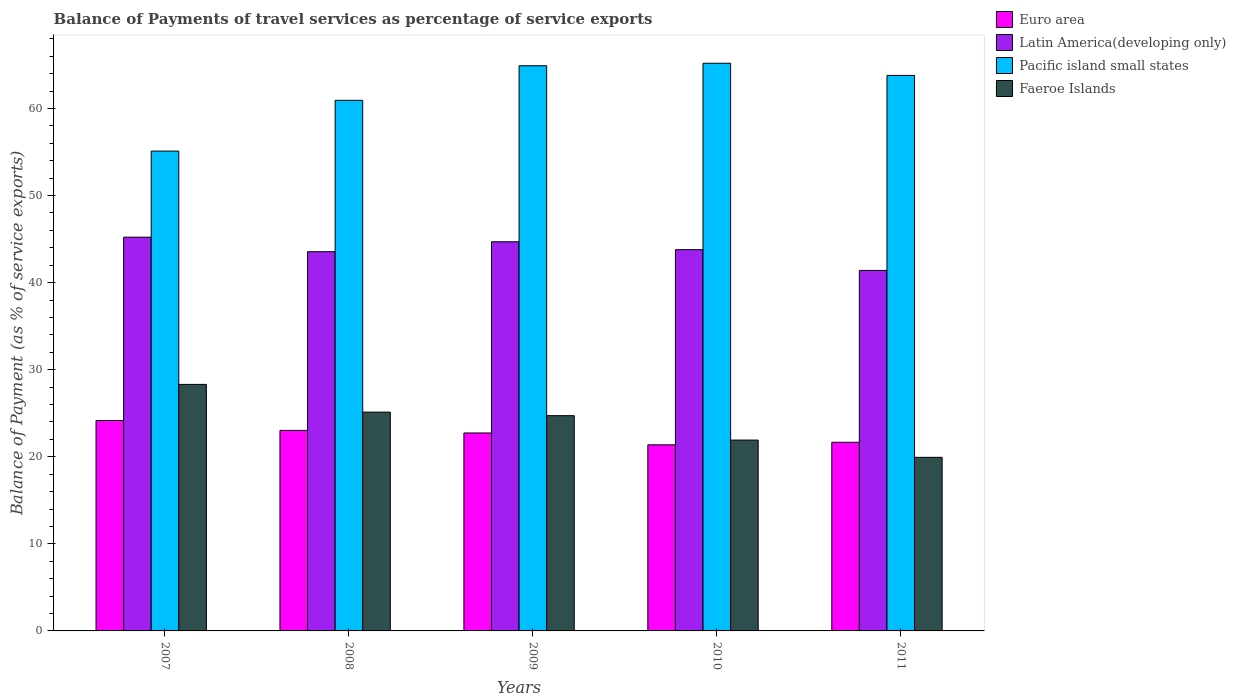How many groups of bars are there?
Keep it short and to the point. 5. Are the number of bars on each tick of the X-axis equal?
Offer a terse response. Yes. How many bars are there on the 3rd tick from the left?
Give a very brief answer. 4. How many bars are there on the 3rd tick from the right?
Give a very brief answer. 4. What is the label of the 2nd group of bars from the left?
Offer a very short reply. 2008. In how many cases, is the number of bars for a given year not equal to the number of legend labels?
Offer a very short reply. 0. What is the balance of payments of travel services in Pacific island small states in 2010?
Offer a terse response. 65.19. Across all years, what is the maximum balance of payments of travel services in Latin America(developing only)?
Keep it short and to the point. 45.22. Across all years, what is the minimum balance of payments of travel services in Faeroe Islands?
Give a very brief answer. 19.94. In which year was the balance of payments of travel services in Faeroe Islands maximum?
Keep it short and to the point. 2007. In which year was the balance of payments of travel services in Pacific island small states minimum?
Offer a very short reply. 2007. What is the total balance of payments of travel services in Faeroe Islands in the graph?
Make the answer very short. 120.01. What is the difference between the balance of payments of travel services in Euro area in 2009 and that in 2011?
Your answer should be compact. 1.07. What is the difference between the balance of payments of travel services in Euro area in 2008 and the balance of payments of travel services in Faeroe Islands in 2011?
Your answer should be very brief. 3.09. What is the average balance of payments of travel services in Latin America(developing only) per year?
Make the answer very short. 43.73. In the year 2009, what is the difference between the balance of payments of travel services in Pacific island small states and balance of payments of travel services in Euro area?
Offer a very short reply. 42.17. What is the ratio of the balance of payments of travel services in Euro area in 2008 to that in 2009?
Offer a terse response. 1.01. Is the balance of payments of travel services in Euro area in 2007 less than that in 2008?
Give a very brief answer. No. What is the difference between the highest and the second highest balance of payments of travel services in Pacific island small states?
Ensure brevity in your answer.  0.28. What is the difference between the highest and the lowest balance of payments of travel services in Latin America(developing only)?
Provide a short and direct response. 3.82. What does the 4th bar from the left in 2009 represents?
Give a very brief answer. Faeroe Islands. What does the 3rd bar from the right in 2009 represents?
Offer a terse response. Latin America(developing only). How many bars are there?
Provide a succinct answer. 20. How many years are there in the graph?
Ensure brevity in your answer.  5. Does the graph contain any zero values?
Give a very brief answer. No. Where does the legend appear in the graph?
Keep it short and to the point. Top right. What is the title of the graph?
Your answer should be very brief. Balance of Payments of travel services as percentage of service exports. Does "Azerbaijan" appear as one of the legend labels in the graph?
Your response must be concise. No. What is the label or title of the Y-axis?
Offer a terse response. Balance of Payment (as % of service exports). What is the Balance of Payment (as % of service exports) of Euro area in 2007?
Give a very brief answer. 24.17. What is the Balance of Payment (as % of service exports) in Latin America(developing only) in 2007?
Provide a succinct answer. 45.22. What is the Balance of Payment (as % of service exports) in Pacific island small states in 2007?
Your answer should be very brief. 55.1. What is the Balance of Payment (as % of service exports) of Faeroe Islands in 2007?
Your answer should be compact. 28.31. What is the Balance of Payment (as % of service exports) of Euro area in 2008?
Provide a short and direct response. 23.03. What is the Balance of Payment (as % of service exports) in Latin America(developing only) in 2008?
Your answer should be very brief. 43.55. What is the Balance of Payment (as % of service exports) of Pacific island small states in 2008?
Your answer should be very brief. 60.94. What is the Balance of Payment (as % of service exports) of Faeroe Islands in 2008?
Ensure brevity in your answer.  25.13. What is the Balance of Payment (as % of service exports) in Euro area in 2009?
Offer a terse response. 22.73. What is the Balance of Payment (as % of service exports) in Latin America(developing only) in 2009?
Offer a terse response. 44.69. What is the Balance of Payment (as % of service exports) of Pacific island small states in 2009?
Your answer should be compact. 64.91. What is the Balance of Payment (as % of service exports) of Faeroe Islands in 2009?
Offer a very short reply. 24.72. What is the Balance of Payment (as % of service exports) of Euro area in 2010?
Provide a succinct answer. 21.37. What is the Balance of Payment (as % of service exports) of Latin America(developing only) in 2010?
Make the answer very short. 43.78. What is the Balance of Payment (as % of service exports) in Pacific island small states in 2010?
Ensure brevity in your answer.  65.19. What is the Balance of Payment (as % of service exports) of Faeroe Islands in 2010?
Your response must be concise. 21.92. What is the Balance of Payment (as % of service exports) in Euro area in 2011?
Offer a very short reply. 21.66. What is the Balance of Payment (as % of service exports) in Latin America(developing only) in 2011?
Keep it short and to the point. 41.4. What is the Balance of Payment (as % of service exports) in Pacific island small states in 2011?
Provide a succinct answer. 63.8. What is the Balance of Payment (as % of service exports) of Faeroe Islands in 2011?
Keep it short and to the point. 19.94. Across all years, what is the maximum Balance of Payment (as % of service exports) of Euro area?
Your answer should be very brief. 24.17. Across all years, what is the maximum Balance of Payment (as % of service exports) of Latin America(developing only)?
Your response must be concise. 45.22. Across all years, what is the maximum Balance of Payment (as % of service exports) in Pacific island small states?
Your response must be concise. 65.19. Across all years, what is the maximum Balance of Payment (as % of service exports) in Faeroe Islands?
Your response must be concise. 28.31. Across all years, what is the minimum Balance of Payment (as % of service exports) in Euro area?
Provide a short and direct response. 21.37. Across all years, what is the minimum Balance of Payment (as % of service exports) of Latin America(developing only)?
Provide a short and direct response. 41.4. Across all years, what is the minimum Balance of Payment (as % of service exports) of Pacific island small states?
Ensure brevity in your answer.  55.1. Across all years, what is the minimum Balance of Payment (as % of service exports) of Faeroe Islands?
Your response must be concise. 19.94. What is the total Balance of Payment (as % of service exports) in Euro area in the graph?
Your answer should be compact. 112.96. What is the total Balance of Payment (as % of service exports) of Latin America(developing only) in the graph?
Provide a succinct answer. 218.64. What is the total Balance of Payment (as % of service exports) in Pacific island small states in the graph?
Ensure brevity in your answer.  309.93. What is the total Balance of Payment (as % of service exports) in Faeroe Islands in the graph?
Offer a terse response. 120.01. What is the difference between the Balance of Payment (as % of service exports) of Euro area in 2007 and that in 2008?
Your answer should be very brief. 1.14. What is the difference between the Balance of Payment (as % of service exports) in Latin America(developing only) in 2007 and that in 2008?
Provide a short and direct response. 1.67. What is the difference between the Balance of Payment (as % of service exports) in Pacific island small states in 2007 and that in 2008?
Offer a terse response. -5.83. What is the difference between the Balance of Payment (as % of service exports) in Faeroe Islands in 2007 and that in 2008?
Ensure brevity in your answer.  3.18. What is the difference between the Balance of Payment (as % of service exports) of Euro area in 2007 and that in 2009?
Ensure brevity in your answer.  1.43. What is the difference between the Balance of Payment (as % of service exports) of Latin America(developing only) in 2007 and that in 2009?
Offer a terse response. 0.53. What is the difference between the Balance of Payment (as % of service exports) of Pacific island small states in 2007 and that in 2009?
Make the answer very short. -9.8. What is the difference between the Balance of Payment (as % of service exports) of Faeroe Islands in 2007 and that in 2009?
Make the answer very short. 3.59. What is the difference between the Balance of Payment (as % of service exports) of Euro area in 2007 and that in 2010?
Provide a succinct answer. 2.79. What is the difference between the Balance of Payment (as % of service exports) in Latin America(developing only) in 2007 and that in 2010?
Make the answer very short. 1.43. What is the difference between the Balance of Payment (as % of service exports) in Pacific island small states in 2007 and that in 2010?
Keep it short and to the point. -10.09. What is the difference between the Balance of Payment (as % of service exports) of Faeroe Islands in 2007 and that in 2010?
Give a very brief answer. 6.39. What is the difference between the Balance of Payment (as % of service exports) of Euro area in 2007 and that in 2011?
Offer a very short reply. 2.5. What is the difference between the Balance of Payment (as % of service exports) in Latin America(developing only) in 2007 and that in 2011?
Provide a succinct answer. 3.82. What is the difference between the Balance of Payment (as % of service exports) of Pacific island small states in 2007 and that in 2011?
Your answer should be very brief. -8.69. What is the difference between the Balance of Payment (as % of service exports) in Faeroe Islands in 2007 and that in 2011?
Provide a short and direct response. 8.37. What is the difference between the Balance of Payment (as % of service exports) in Euro area in 2008 and that in 2009?
Offer a terse response. 0.3. What is the difference between the Balance of Payment (as % of service exports) in Latin America(developing only) in 2008 and that in 2009?
Offer a very short reply. -1.14. What is the difference between the Balance of Payment (as % of service exports) in Pacific island small states in 2008 and that in 2009?
Ensure brevity in your answer.  -3.97. What is the difference between the Balance of Payment (as % of service exports) of Faeroe Islands in 2008 and that in 2009?
Give a very brief answer. 0.41. What is the difference between the Balance of Payment (as % of service exports) in Euro area in 2008 and that in 2010?
Provide a short and direct response. 1.66. What is the difference between the Balance of Payment (as % of service exports) of Latin America(developing only) in 2008 and that in 2010?
Your answer should be compact. -0.23. What is the difference between the Balance of Payment (as % of service exports) of Pacific island small states in 2008 and that in 2010?
Ensure brevity in your answer.  -4.25. What is the difference between the Balance of Payment (as % of service exports) of Faeroe Islands in 2008 and that in 2010?
Your response must be concise. 3.21. What is the difference between the Balance of Payment (as % of service exports) in Euro area in 2008 and that in 2011?
Your response must be concise. 1.37. What is the difference between the Balance of Payment (as % of service exports) in Latin America(developing only) in 2008 and that in 2011?
Provide a succinct answer. 2.15. What is the difference between the Balance of Payment (as % of service exports) in Pacific island small states in 2008 and that in 2011?
Your answer should be compact. -2.86. What is the difference between the Balance of Payment (as % of service exports) of Faeroe Islands in 2008 and that in 2011?
Ensure brevity in your answer.  5.19. What is the difference between the Balance of Payment (as % of service exports) in Euro area in 2009 and that in 2010?
Provide a short and direct response. 1.36. What is the difference between the Balance of Payment (as % of service exports) in Latin America(developing only) in 2009 and that in 2010?
Offer a terse response. 0.91. What is the difference between the Balance of Payment (as % of service exports) of Pacific island small states in 2009 and that in 2010?
Keep it short and to the point. -0.28. What is the difference between the Balance of Payment (as % of service exports) of Faeroe Islands in 2009 and that in 2010?
Make the answer very short. 2.8. What is the difference between the Balance of Payment (as % of service exports) of Euro area in 2009 and that in 2011?
Offer a very short reply. 1.07. What is the difference between the Balance of Payment (as % of service exports) of Latin America(developing only) in 2009 and that in 2011?
Provide a succinct answer. 3.29. What is the difference between the Balance of Payment (as % of service exports) of Pacific island small states in 2009 and that in 2011?
Your answer should be very brief. 1.11. What is the difference between the Balance of Payment (as % of service exports) of Faeroe Islands in 2009 and that in 2011?
Make the answer very short. 4.78. What is the difference between the Balance of Payment (as % of service exports) in Euro area in 2010 and that in 2011?
Keep it short and to the point. -0.29. What is the difference between the Balance of Payment (as % of service exports) of Latin America(developing only) in 2010 and that in 2011?
Keep it short and to the point. 2.38. What is the difference between the Balance of Payment (as % of service exports) of Pacific island small states in 2010 and that in 2011?
Your response must be concise. 1.4. What is the difference between the Balance of Payment (as % of service exports) of Faeroe Islands in 2010 and that in 2011?
Offer a terse response. 1.98. What is the difference between the Balance of Payment (as % of service exports) of Euro area in 2007 and the Balance of Payment (as % of service exports) of Latin America(developing only) in 2008?
Make the answer very short. -19.38. What is the difference between the Balance of Payment (as % of service exports) in Euro area in 2007 and the Balance of Payment (as % of service exports) in Pacific island small states in 2008?
Offer a very short reply. -36.77. What is the difference between the Balance of Payment (as % of service exports) in Euro area in 2007 and the Balance of Payment (as % of service exports) in Faeroe Islands in 2008?
Keep it short and to the point. -0.96. What is the difference between the Balance of Payment (as % of service exports) in Latin America(developing only) in 2007 and the Balance of Payment (as % of service exports) in Pacific island small states in 2008?
Your answer should be compact. -15.72. What is the difference between the Balance of Payment (as % of service exports) in Latin America(developing only) in 2007 and the Balance of Payment (as % of service exports) in Faeroe Islands in 2008?
Keep it short and to the point. 20.09. What is the difference between the Balance of Payment (as % of service exports) in Pacific island small states in 2007 and the Balance of Payment (as % of service exports) in Faeroe Islands in 2008?
Your response must be concise. 29.98. What is the difference between the Balance of Payment (as % of service exports) in Euro area in 2007 and the Balance of Payment (as % of service exports) in Latin America(developing only) in 2009?
Keep it short and to the point. -20.53. What is the difference between the Balance of Payment (as % of service exports) in Euro area in 2007 and the Balance of Payment (as % of service exports) in Pacific island small states in 2009?
Make the answer very short. -40.74. What is the difference between the Balance of Payment (as % of service exports) of Euro area in 2007 and the Balance of Payment (as % of service exports) of Faeroe Islands in 2009?
Your answer should be very brief. -0.55. What is the difference between the Balance of Payment (as % of service exports) in Latin America(developing only) in 2007 and the Balance of Payment (as % of service exports) in Pacific island small states in 2009?
Your answer should be very brief. -19.69. What is the difference between the Balance of Payment (as % of service exports) of Latin America(developing only) in 2007 and the Balance of Payment (as % of service exports) of Faeroe Islands in 2009?
Offer a very short reply. 20.5. What is the difference between the Balance of Payment (as % of service exports) in Pacific island small states in 2007 and the Balance of Payment (as % of service exports) in Faeroe Islands in 2009?
Offer a very short reply. 30.39. What is the difference between the Balance of Payment (as % of service exports) of Euro area in 2007 and the Balance of Payment (as % of service exports) of Latin America(developing only) in 2010?
Keep it short and to the point. -19.62. What is the difference between the Balance of Payment (as % of service exports) in Euro area in 2007 and the Balance of Payment (as % of service exports) in Pacific island small states in 2010?
Keep it short and to the point. -41.02. What is the difference between the Balance of Payment (as % of service exports) of Euro area in 2007 and the Balance of Payment (as % of service exports) of Faeroe Islands in 2010?
Keep it short and to the point. 2.25. What is the difference between the Balance of Payment (as % of service exports) of Latin America(developing only) in 2007 and the Balance of Payment (as % of service exports) of Pacific island small states in 2010?
Keep it short and to the point. -19.97. What is the difference between the Balance of Payment (as % of service exports) of Latin America(developing only) in 2007 and the Balance of Payment (as % of service exports) of Faeroe Islands in 2010?
Give a very brief answer. 23.3. What is the difference between the Balance of Payment (as % of service exports) of Pacific island small states in 2007 and the Balance of Payment (as % of service exports) of Faeroe Islands in 2010?
Your answer should be very brief. 33.19. What is the difference between the Balance of Payment (as % of service exports) in Euro area in 2007 and the Balance of Payment (as % of service exports) in Latin America(developing only) in 2011?
Provide a succinct answer. -17.23. What is the difference between the Balance of Payment (as % of service exports) of Euro area in 2007 and the Balance of Payment (as % of service exports) of Pacific island small states in 2011?
Provide a short and direct response. -39.63. What is the difference between the Balance of Payment (as % of service exports) of Euro area in 2007 and the Balance of Payment (as % of service exports) of Faeroe Islands in 2011?
Keep it short and to the point. 4.23. What is the difference between the Balance of Payment (as % of service exports) of Latin America(developing only) in 2007 and the Balance of Payment (as % of service exports) of Pacific island small states in 2011?
Offer a very short reply. -18.58. What is the difference between the Balance of Payment (as % of service exports) in Latin America(developing only) in 2007 and the Balance of Payment (as % of service exports) in Faeroe Islands in 2011?
Ensure brevity in your answer.  25.28. What is the difference between the Balance of Payment (as % of service exports) of Pacific island small states in 2007 and the Balance of Payment (as % of service exports) of Faeroe Islands in 2011?
Offer a very short reply. 35.17. What is the difference between the Balance of Payment (as % of service exports) of Euro area in 2008 and the Balance of Payment (as % of service exports) of Latin America(developing only) in 2009?
Make the answer very short. -21.66. What is the difference between the Balance of Payment (as % of service exports) of Euro area in 2008 and the Balance of Payment (as % of service exports) of Pacific island small states in 2009?
Keep it short and to the point. -41.88. What is the difference between the Balance of Payment (as % of service exports) of Euro area in 2008 and the Balance of Payment (as % of service exports) of Faeroe Islands in 2009?
Give a very brief answer. -1.69. What is the difference between the Balance of Payment (as % of service exports) of Latin America(developing only) in 2008 and the Balance of Payment (as % of service exports) of Pacific island small states in 2009?
Keep it short and to the point. -21.36. What is the difference between the Balance of Payment (as % of service exports) of Latin America(developing only) in 2008 and the Balance of Payment (as % of service exports) of Faeroe Islands in 2009?
Provide a short and direct response. 18.83. What is the difference between the Balance of Payment (as % of service exports) of Pacific island small states in 2008 and the Balance of Payment (as % of service exports) of Faeroe Islands in 2009?
Give a very brief answer. 36.22. What is the difference between the Balance of Payment (as % of service exports) of Euro area in 2008 and the Balance of Payment (as % of service exports) of Latin America(developing only) in 2010?
Your answer should be very brief. -20.75. What is the difference between the Balance of Payment (as % of service exports) of Euro area in 2008 and the Balance of Payment (as % of service exports) of Pacific island small states in 2010?
Ensure brevity in your answer.  -42.16. What is the difference between the Balance of Payment (as % of service exports) in Euro area in 2008 and the Balance of Payment (as % of service exports) in Faeroe Islands in 2010?
Your answer should be very brief. 1.11. What is the difference between the Balance of Payment (as % of service exports) of Latin America(developing only) in 2008 and the Balance of Payment (as % of service exports) of Pacific island small states in 2010?
Keep it short and to the point. -21.64. What is the difference between the Balance of Payment (as % of service exports) in Latin America(developing only) in 2008 and the Balance of Payment (as % of service exports) in Faeroe Islands in 2010?
Keep it short and to the point. 21.63. What is the difference between the Balance of Payment (as % of service exports) in Pacific island small states in 2008 and the Balance of Payment (as % of service exports) in Faeroe Islands in 2010?
Your answer should be very brief. 39.02. What is the difference between the Balance of Payment (as % of service exports) of Euro area in 2008 and the Balance of Payment (as % of service exports) of Latin America(developing only) in 2011?
Provide a succinct answer. -18.37. What is the difference between the Balance of Payment (as % of service exports) of Euro area in 2008 and the Balance of Payment (as % of service exports) of Pacific island small states in 2011?
Offer a very short reply. -40.77. What is the difference between the Balance of Payment (as % of service exports) of Euro area in 2008 and the Balance of Payment (as % of service exports) of Faeroe Islands in 2011?
Offer a very short reply. 3.09. What is the difference between the Balance of Payment (as % of service exports) in Latin America(developing only) in 2008 and the Balance of Payment (as % of service exports) in Pacific island small states in 2011?
Make the answer very short. -20.25. What is the difference between the Balance of Payment (as % of service exports) in Latin America(developing only) in 2008 and the Balance of Payment (as % of service exports) in Faeroe Islands in 2011?
Ensure brevity in your answer.  23.61. What is the difference between the Balance of Payment (as % of service exports) in Euro area in 2009 and the Balance of Payment (as % of service exports) in Latin America(developing only) in 2010?
Offer a very short reply. -21.05. What is the difference between the Balance of Payment (as % of service exports) of Euro area in 2009 and the Balance of Payment (as % of service exports) of Pacific island small states in 2010?
Offer a terse response. -42.46. What is the difference between the Balance of Payment (as % of service exports) in Euro area in 2009 and the Balance of Payment (as % of service exports) in Faeroe Islands in 2010?
Your response must be concise. 0.82. What is the difference between the Balance of Payment (as % of service exports) in Latin America(developing only) in 2009 and the Balance of Payment (as % of service exports) in Pacific island small states in 2010?
Offer a very short reply. -20.5. What is the difference between the Balance of Payment (as % of service exports) of Latin America(developing only) in 2009 and the Balance of Payment (as % of service exports) of Faeroe Islands in 2010?
Offer a very short reply. 22.77. What is the difference between the Balance of Payment (as % of service exports) in Pacific island small states in 2009 and the Balance of Payment (as % of service exports) in Faeroe Islands in 2010?
Ensure brevity in your answer.  42.99. What is the difference between the Balance of Payment (as % of service exports) in Euro area in 2009 and the Balance of Payment (as % of service exports) in Latin America(developing only) in 2011?
Provide a short and direct response. -18.67. What is the difference between the Balance of Payment (as % of service exports) of Euro area in 2009 and the Balance of Payment (as % of service exports) of Pacific island small states in 2011?
Keep it short and to the point. -41.06. What is the difference between the Balance of Payment (as % of service exports) in Euro area in 2009 and the Balance of Payment (as % of service exports) in Faeroe Islands in 2011?
Offer a terse response. 2.8. What is the difference between the Balance of Payment (as % of service exports) in Latin America(developing only) in 2009 and the Balance of Payment (as % of service exports) in Pacific island small states in 2011?
Offer a very short reply. -19.1. What is the difference between the Balance of Payment (as % of service exports) of Latin America(developing only) in 2009 and the Balance of Payment (as % of service exports) of Faeroe Islands in 2011?
Give a very brief answer. 24.76. What is the difference between the Balance of Payment (as % of service exports) in Pacific island small states in 2009 and the Balance of Payment (as % of service exports) in Faeroe Islands in 2011?
Offer a terse response. 44.97. What is the difference between the Balance of Payment (as % of service exports) of Euro area in 2010 and the Balance of Payment (as % of service exports) of Latin America(developing only) in 2011?
Your answer should be very brief. -20.03. What is the difference between the Balance of Payment (as % of service exports) in Euro area in 2010 and the Balance of Payment (as % of service exports) in Pacific island small states in 2011?
Provide a succinct answer. -42.42. What is the difference between the Balance of Payment (as % of service exports) in Euro area in 2010 and the Balance of Payment (as % of service exports) in Faeroe Islands in 2011?
Your response must be concise. 1.44. What is the difference between the Balance of Payment (as % of service exports) in Latin America(developing only) in 2010 and the Balance of Payment (as % of service exports) in Pacific island small states in 2011?
Your response must be concise. -20.01. What is the difference between the Balance of Payment (as % of service exports) of Latin America(developing only) in 2010 and the Balance of Payment (as % of service exports) of Faeroe Islands in 2011?
Ensure brevity in your answer.  23.85. What is the difference between the Balance of Payment (as % of service exports) of Pacific island small states in 2010 and the Balance of Payment (as % of service exports) of Faeroe Islands in 2011?
Make the answer very short. 45.26. What is the average Balance of Payment (as % of service exports) in Euro area per year?
Keep it short and to the point. 22.59. What is the average Balance of Payment (as % of service exports) in Latin America(developing only) per year?
Make the answer very short. 43.73. What is the average Balance of Payment (as % of service exports) in Pacific island small states per year?
Make the answer very short. 61.99. What is the average Balance of Payment (as % of service exports) of Faeroe Islands per year?
Your answer should be compact. 24. In the year 2007, what is the difference between the Balance of Payment (as % of service exports) of Euro area and Balance of Payment (as % of service exports) of Latin America(developing only)?
Offer a very short reply. -21.05. In the year 2007, what is the difference between the Balance of Payment (as % of service exports) of Euro area and Balance of Payment (as % of service exports) of Pacific island small states?
Your response must be concise. -30.94. In the year 2007, what is the difference between the Balance of Payment (as % of service exports) of Euro area and Balance of Payment (as % of service exports) of Faeroe Islands?
Provide a succinct answer. -4.14. In the year 2007, what is the difference between the Balance of Payment (as % of service exports) of Latin America(developing only) and Balance of Payment (as % of service exports) of Pacific island small states?
Keep it short and to the point. -9.89. In the year 2007, what is the difference between the Balance of Payment (as % of service exports) of Latin America(developing only) and Balance of Payment (as % of service exports) of Faeroe Islands?
Your answer should be very brief. 16.91. In the year 2007, what is the difference between the Balance of Payment (as % of service exports) in Pacific island small states and Balance of Payment (as % of service exports) in Faeroe Islands?
Make the answer very short. 26.79. In the year 2008, what is the difference between the Balance of Payment (as % of service exports) in Euro area and Balance of Payment (as % of service exports) in Latin America(developing only)?
Keep it short and to the point. -20.52. In the year 2008, what is the difference between the Balance of Payment (as % of service exports) of Euro area and Balance of Payment (as % of service exports) of Pacific island small states?
Give a very brief answer. -37.91. In the year 2008, what is the difference between the Balance of Payment (as % of service exports) of Euro area and Balance of Payment (as % of service exports) of Faeroe Islands?
Your answer should be compact. -2.1. In the year 2008, what is the difference between the Balance of Payment (as % of service exports) of Latin America(developing only) and Balance of Payment (as % of service exports) of Pacific island small states?
Provide a succinct answer. -17.39. In the year 2008, what is the difference between the Balance of Payment (as % of service exports) of Latin America(developing only) and Balance of Payment (as % of service exports) of Faeroe Islands?
Your answer should be compact. 18.42. In the year 2008, what is the difference between the Balance of Payment (as % of service exports) in Pacific island small states and Balance of Payment (as % of service exports) in Faeroe Islands?
Provide a succinct answer. 35.81. In the year 2009, what is the difference between the Balance of Payment (as % of service exports) of Euro area and Balance of Payment (as % of service exports) of Latin America(developing only)?
Provide a succinct answer. -21.96. In the year 2009, what is the difference between the Balance of Payment (as % of service exports) of Euro area and Balance of Payment (as % of service exports) of Pacific island small states?
Your answer should be very brief. -42.17. In the year 2009, what is the difference between the Balance of Payment (as % of service exports) in Euro area and Balance of Payment (as % of service exports) in Faeroe Islands?
Keep it short and to the point. -1.99. In the year 2009, what is the difference between the Balance of Payment (as % of service exports) of Latin America(developing only) and Balance of Payment (as % of service exports) of Pacific island small states?
Offer a very short reply. -20.21. In the year 2009, what is the difference between the Balance of Payment (as % of service exports) of Latin America(developing only) and Balance of Payment (as % of service exports) of Faeroe Islands?
Ensure brevity in your answer.  19.97. In the year 2009, what is the difference between the Balance of Payment (as % of service exports) of Pacific island small states and Balance of Payment (as % of service exports) of Faeroe Islands?
Keep it short and to the point. 40.19. In the year 2010, what is the difference between the Balance of Payment (as % of service exports) of Euro area and Balance of Payment (as % of service exports) of Latin America(developing only)?
Your response must be concise. -22.41. In the year 2010, what is the difference between the Balance of Payment (as % of service exports) of Euro area and Balance of Payment (as % of service exports) of Pacific island small states?
Keep it short and to the point. -43.82. In the year 2010, what is the difference between the Balance of Payment (as % of service exports) of Euro area and Balance of Payment (as % of service exports) of Faeroe Islands?
Provide a short and direct response. -0.54. In the year 2010, what is the difference between the Balance of Payment (as % of service exports) in Latin America(developing only) and Balance of Payment (as % of service exports) in Pacific island small states?
Offer a terse response. -21.41. In the year 2010, what is the difference between the Balance of Payment (as % of service exports) in Latin America(developing only) and Balance of Payment (as % of service exports) in Faeroe Islands?
Your answer should be compact. 21.87. In the year 2010, what is the difference between the Balance of Payment (as % of service exports) in Pacific island small states and Balance of Payment (as % of service exports) in Faeroe Islands?
Make the answer very short. 43.27. In the year 2011, what is the difference between the Balance of Payment (as % of service exports) of Euro area and Balance of Payment (as % of service exports) of Latin America(developing only)?
Make the answer very short. -19.74. In the year 2011, what is the difference between the Balance of Payment (as % of service exports) in Euro area and Balance of Payment (as % of service exports) in Pacific island small states?
Make the answer very short. -42.13. In the year 2011, what is the difference between the Balance of Payment (as % of service exports) in Euro area and Balance of Payment (as % of service exports) in Faeroe Islands?
Provide a short and direct response. 1.73. In the year 2011, what is the difference between the Balance of Payment (as % of service exports) of Latin America(developing only) and Balance of Payment (as % of service exports) of Pacific island small states?
Make the answer very short. -22.4. In the year 2011, what is the difference between the Balance of Payment (as % of service exports) of Latin America(developing only) and Balance of Payment (as % of service exports) of Faeroe Islands?
Provide a succinct answer. 21.46. In the year 2011, what is the difference between the Balance of Payment (as % of service exports) of Pacific island small states and Balance of Payment (as % of service exports) of Faeroe Islands?
Ensure brevity in your answer.  43.86. What is the ratio of the Balance of Payment (as % of service exports) in Euro area in 2007 to that in 2008?
Make the answer very short. 1.05. What is the ratio of the Balance of Payment (as % of service exports) in Latin America(developing only) in 2007 to that in 2008?
Offer a very short reply. 1.04. What is the ratio of the Balance of Payment (as % of service exports) of Pacific island small states in 2007 to that in 2008?
Offer a terse response. 0.9. What is the ratio of the Balance of Payment (as % of service exports) in Faeroe Islands in 2007 to that in 2008?
Provide a succinct answer. 1.13. What is the ratio of the Balance of Payment (as % of service exports) of Euro area in 2007 to that in 2009?
Offer a very short reply. 1.06. What is the ratio of the Balance of Payment (as % of service exports) of Latin America(developing only) in 2007 to that in 2009?
Your answer should be very brief. 1.01. What is the ratio of the Balance of Payment (as % of service exports) in Pacific island small states in 2007 to that in 2009?
Provide a short and direct response. 0.85. What is the ratio of the Balance of Payment (as % of service exports) in Faeroe Islands in 2007 to that in 2009?
Offer a very short reply. 1.15. What is the ratio of the Balance of Payment (as % of service exports) of Euro area in 2007 to that in 2010?
Your answer should be very brief. 1.13. What is the ratio of the Balance of Payment (as % of service exports) in Latin America(developing only) in 2007 to that in 2010?
Give a very brief answer. 1.03. What is the ratio of the Balance of Payment (as % of service exports) of Pacific island small states in 2007 to that in 2010?
Provide a short and direct response. 0.85. What is the ratio of the Balance of Payment (as % of service exports) in Faeroe Islands in 2007 to that in 2010?
Keep it short and to the point. 1.29. What is the ratio of the Balance of Payment (as % of service exports) in Euro area in 2007 to that in 2011?
Your answer should be compact. 1.12. What is the ratio of the Balance of Payment (as % of service exports) of Latin America(developing only) in 2007 to that in 2011?
Keep it short and to the point. 1.09. What is the ratio of the Balance of Payment (as % of service exports) of Pacific island small states in 2007 to that in 2011?
Your answer should be compact. 0.86. What is the ratio of the Balance of Payment (as % of service exports) in Faeroe Islands in 2007 to that in 2011?
Your response must be concise. 1.42. What is the ratio of the Balance of Payment (as % of service exports) in Euro area in 2008 to that in 2009?
Give a very brief answer. 1.01. What is the ratio of the Balance of Payment (as % of service exports) of Latin America(developing only) in 2008 to that in 2009?
Ensure brevity in your answer.  0.97. What is the ratio of the Balance of Payment (as % of service exports) of Pacific island small states in 2008 to that in 2009?
Offer a very short reply. 0.94. What is the ratio of the Balance of Payment (as % of service exports) of Faeroe Islands in 2008 to that in 2009?
Make the answer very short. 1.02. What is the ratio of the Balance of Payment (as % of service exports) of Euro area in 2008 to that in 2010?
Your response must be concise. 1.08. What is the ratio of the Balance of Payment (as % of service exports) in Pacific island small states in 2008 to that in 2010?
Provide a short and direct response. 0.93. What is the ratio of the Balance of Payment (as % of service exports) of Faeroe Islands in 2008 to that in 2010?
Provide a succinct answer. 1.15. What is the ratio of the Balance of Payment (as % of service exports) of Euro area in 2008 to that in 2011?
Keep it short and to the point. 1.06. What is the ratio of the Balance of Payment (as % of service exports) of Latin America(developing only) in 2008 to that in 2011?
Ensure brevity in your answer.  1.05. What is the ratio of the Balance of Payment (as % of service exports) in Pacific island small states in 2008 to that in 2011?
Keep it short and to the point. 0.96. What is the ratio of the Balance of Payment (as % of service exports) in Faeroe Islands in 2008 to that in 2011?
Your response must be concise. 1.26. What is the ratio of the Balance of Payment (as % of service exports) of Euro area in 2009 to that in 2010?
Provide a succinct answer. 1.06. What is the ratio of the Balance of Payment (as % of service exports) in Latin America(developing only) in 2009 to that in 2010?
Keep it short and to the point. 1.02. What is the ratio of the Balance of Payment (as % of service exports) of Pacific island small states in 2009 to that in 2010?
Your answer should be compact. 1. What is the ratio of the Balance of Payment (as % of service exports) in Faeroe Islands in 2009 to that in 2010?
Make the answer very short. 1.13. What is the ratio of the Balance of Payment (as % of service exports) of Euro area in 2009 to that in 2011?
Ensure brevity in your answer.  1.05. What is the ratio of the Balance of Payment (as % of service exports) in Latin America(developing only) in 2009 to that in 2011?
Offer a terse response. 1.08. What is the ratio of the Balance of Payment (as % of service exports) of Pacific island small states in 2009 to that in 2011?
Make the answer very short. 1.02. What is the ratio of the Balance of Payment (as % of service exports) of Faeroe Islands in 2009 to that in 2011?
Give a very brief answer. 1.24. What is the ratio of the Balance of Payment (as % of service exports) of Euro area in 2010 to that in 2011?
Offer a terse response. 0.99. What is the ratio of the Balance of Payment (as % of service exports) in Latin America(developing only) in 2010 to that in 2011?
Make the answer very short. 1.06. What is the ratio of the Balance of Payment (as % of service exports) of Pacific island small states in 2010 to that in 2011?
Your answer should be compact. 1.02. What is the ratio of the Balance of Payment (as % of service exports) in Faeroe Islands in 2010 to that in 2011?
Offer a very short reply. 1.1. What is the difference between the highest and the second highest Balance of Payment (as % of service exports) in Euro area?
Ensure brevity in your answer.  1.14. What is the difference between the highest and the second highest Balance of Payment (as % of service exports) in Latin America(developing only)?
Make the answer very short. 0.53. What is the difference between the highest and the second highest Balance of Payment (as % of service exports) in Pacific island small states?
Offer a very short reply. 0.28. What is the difference between the highest and the second highest Balance of Payment (as % of service exports) of Faeroe Islands?
Provide a short and direct response. 3.18. What is the difference between the highest and the lowest Balance of Payment (as % of service exports) of Euro area?
Your response must be concise. 2.79. What is the difference between the highest and the lowest Balance of Payment (as % of service exports) of Latin America(developing only)?
Keep it short and to the point. 3.82. What is the difference between the highest and the lowest Balance of Payment (as % of service exports) of Pacific island small states?
Your answer should be compact. 10.09. What is the difference between the highest and the lowest Balance of Payment (as % of service exports) of Faeroe Islands?
Give a very brief answer. 8.37. 